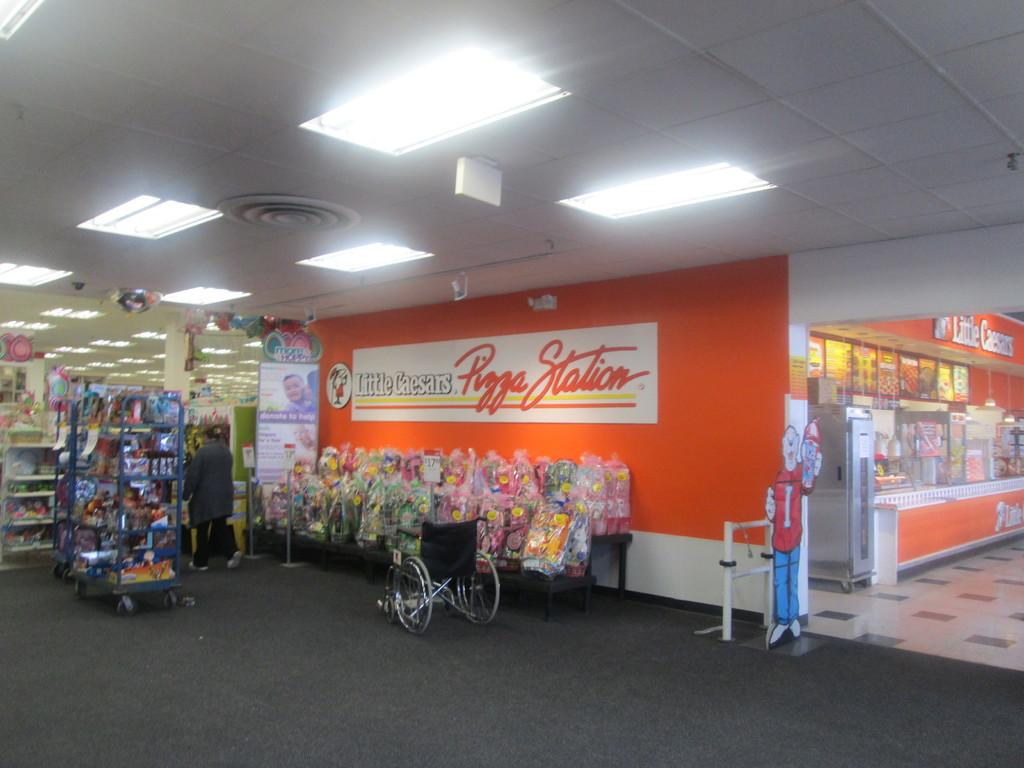Provide a one-sentence caption for the provided image. The Little Caesars Pizza Station appears to be deserted at this time. 